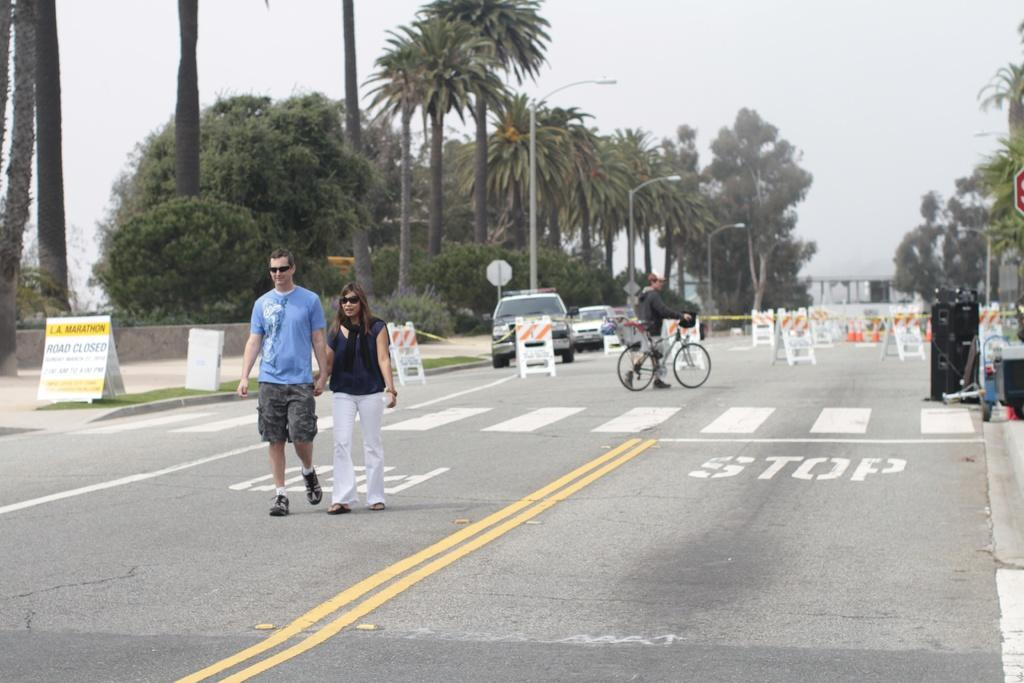What are the people in the image doing? There are persons walking on the main road in the image. What can be seen in the background of the image? There are trees visible in the background, and cars are driving in the background. How would you describe the weather based on the image? The sky appears to be cloudy in the image. How many partners do the trees in the background have? There are no partners mentioned in the image, as it focuses on people walking and the presence of trees and cars in the background. 